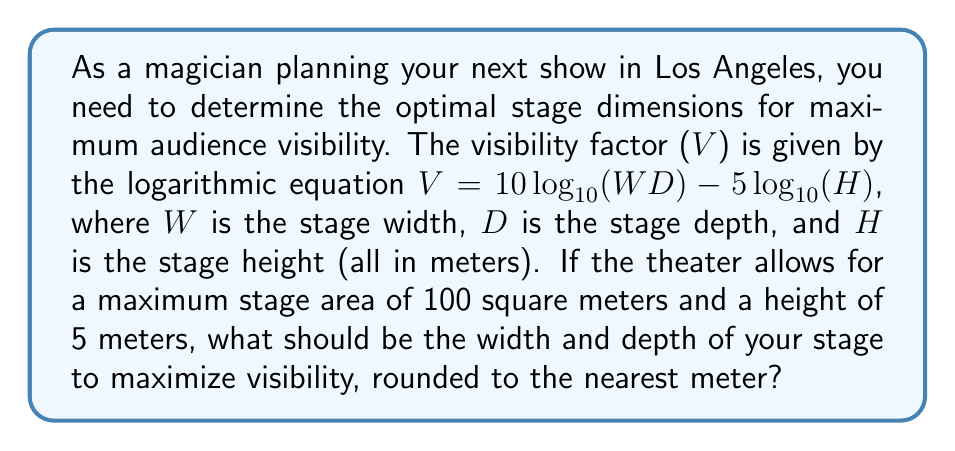What is the answer to this math problem? 1) We need to maximize $V = 10 \log_{10}(WD) - 5 \log_{10}(H)$

2) Given: 
   - Maximum stage area: $WD = 100$ m²
   - Height: $H = 5$ m

3) Substitute these into the equation:
   $V = 10 \log_{10}(100) - 5 \log_{10}(5)$

4) To maximize V, we need to maximize WD while minimizing H. Since H is fixed, we'll use the maximum allowed area for WD.

5) Now, we need to find W and D such that $WD = 100$

6) For a rectangle, the maximum area occurs when it's a square. So:
   $W = D = \sqrt{100} = 10$ m

7) Verify: $10 \times 10 = 100$ m², which meets the area constraint.

8) Round to the nearest meter: W = 10 m, D = 10 m
Answer: Width: 10 m, Depth: 10 m 